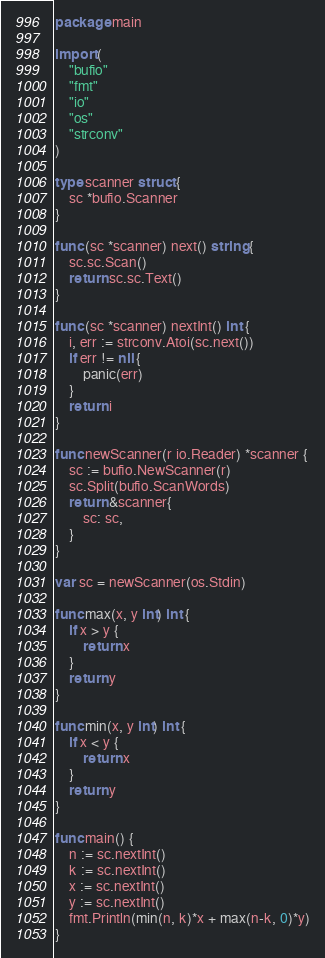<code> <loc_0><loc_0><loc_500><loc_500><_Go_>package main

import (
	"bufio"
	"fmt"
	"io"
	"os"
	"strconv"
)

type scanner struct {
	sc *bufio.Scanner
}

func (sc *scanner) next() string {
	sc.sc.Scan()
	return sc.sc.Text()
}

func (sc *scanner) nextInt() int {
	i, err := strconv.Atoi(sc.next())
	if err != nil {
		panic(err)
	}
	return i
}

func newScanner(r io.Reader) *scanner {
	sc := bufio.NewScanner(r)
	sc.Split(bufio.ScanWords)
	return &scanner{
		sc: sc,
	}
}

var sc = newScanner(os.Stdin)

func max(x, y int) int {
	if x > y {
		return x
	}
	return y
}

func min(x, y int) int {
	if x < y {
		return x
	}
	return y
}

func main() {
	n := sc.nextInt()
	k := sc.nextInt()
	x := sc.nextInt()
	y := sc.nextInt()
	fmt.Println(min(n, k)*x + max(n-k, 0)*y)
}
</code> 